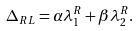Convert formula to latex. <formula><loc_0><loc_0><loc_500><loc_500>\Delta _ { R L } = \alpha \lambda _ { 1 } ^ { R } + \beta \lambda _ { 2 } ^ { R } .</formula> 